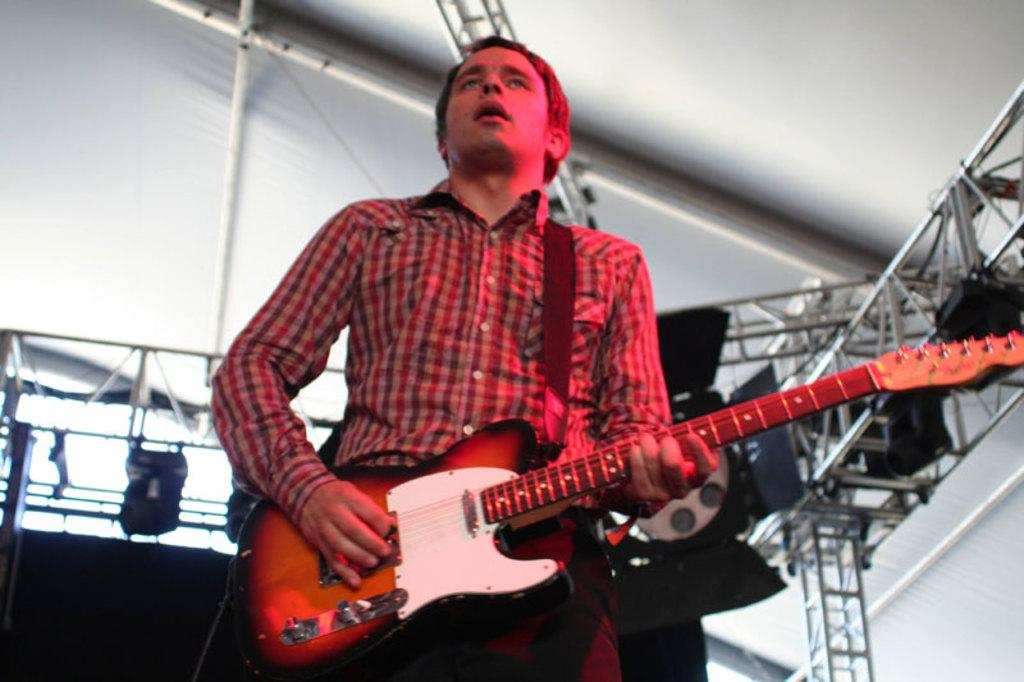What is the main subject of the image? The main subject of the image is a man. What is the man doing in the image? The man is playing a guitar in the image. How many nails can be seen in the image? There is no mention of nails in the image, so it is not possible to determine how many there are. 